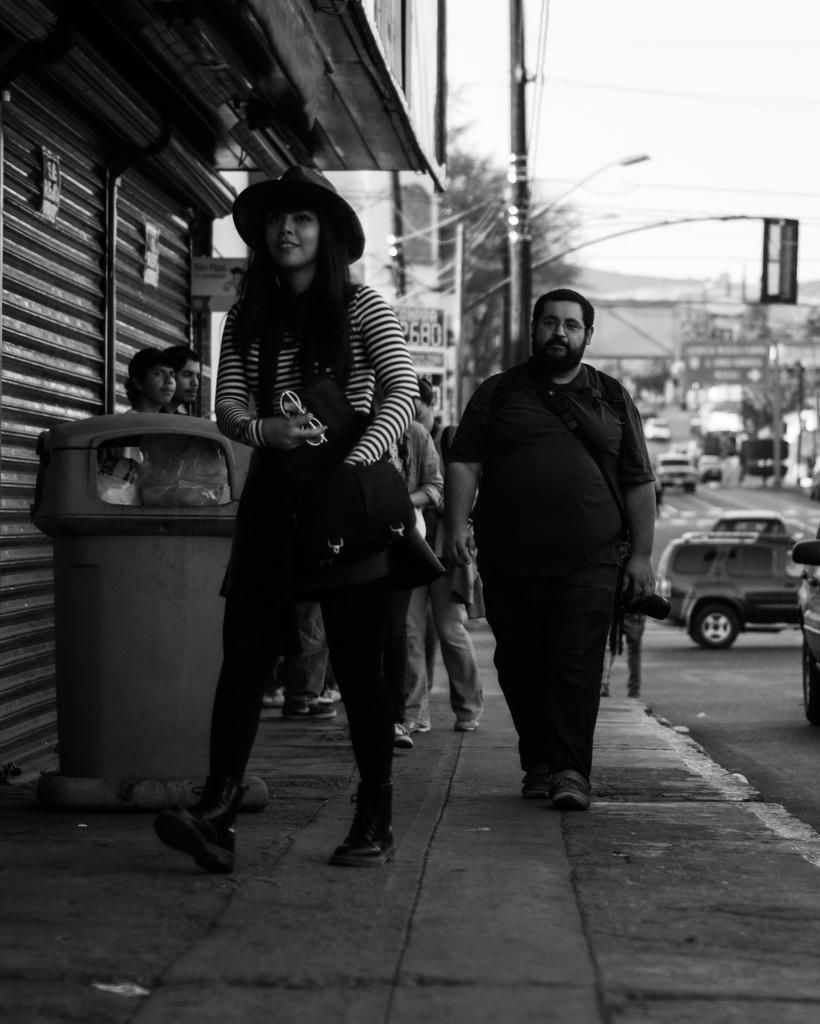How would you summarize this image in a sentence or two? In this photo i see a girl wearing a cap and some people are sitting over here. This is the shutter and some cars are backside of this man. 